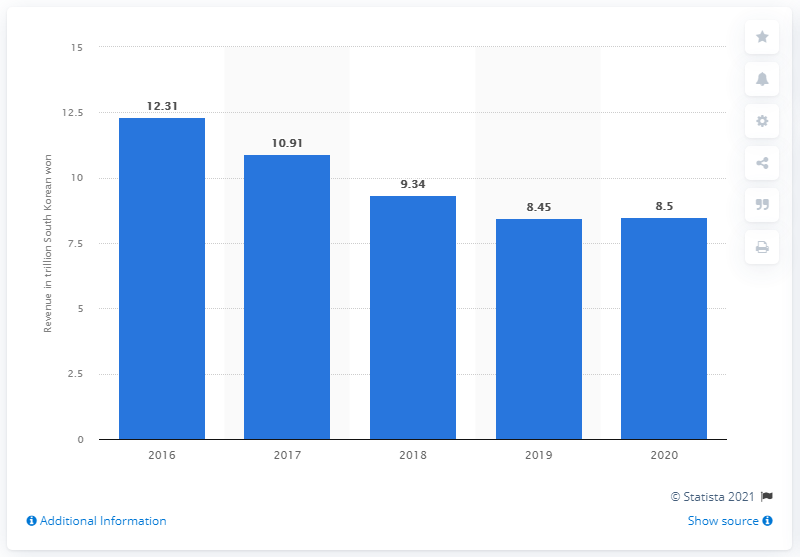Highlight a few significant elements in this photo. According to available information, GM Korea's revenue in 2020 was approximately 8.5 billion US dollars. In the year 2020, GM Korea reported a revenue of approximately 8.5 trillion South Korean won. 